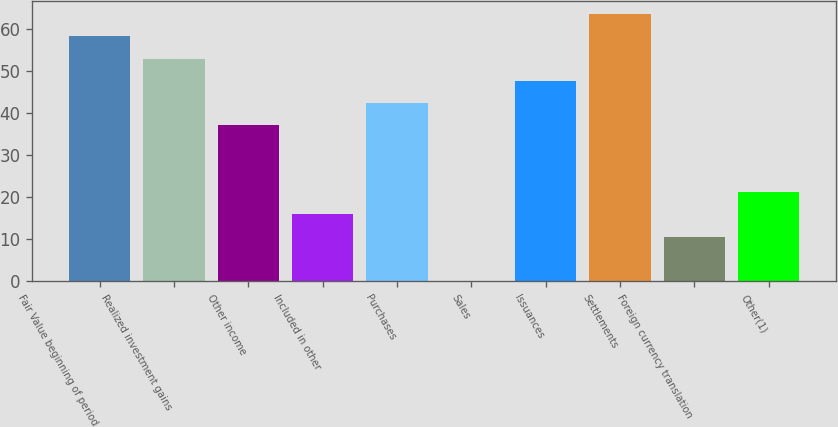Convert chart to OTSL. <chart><loc_0><loc_0><loc_500><loc_500><bar_chart><fcel>Fair Value beginning of period<fcel>Realized investment gains<fcel>Other income<fcel>Included in other<fcel>Purchases<fcel>Sales<fcel>Issuances<fcel>Settlements<fcel>Foreign currency translation<fcel>Other(1)<nl><fcel>58.31<fcel>53.02<fcel>37.15<fcel>15.99<fcel>42.44<fcel>0.12<fcel>47.73<fcel>63.6<fcel>10.7<fcel>21.28<nl></chart> 